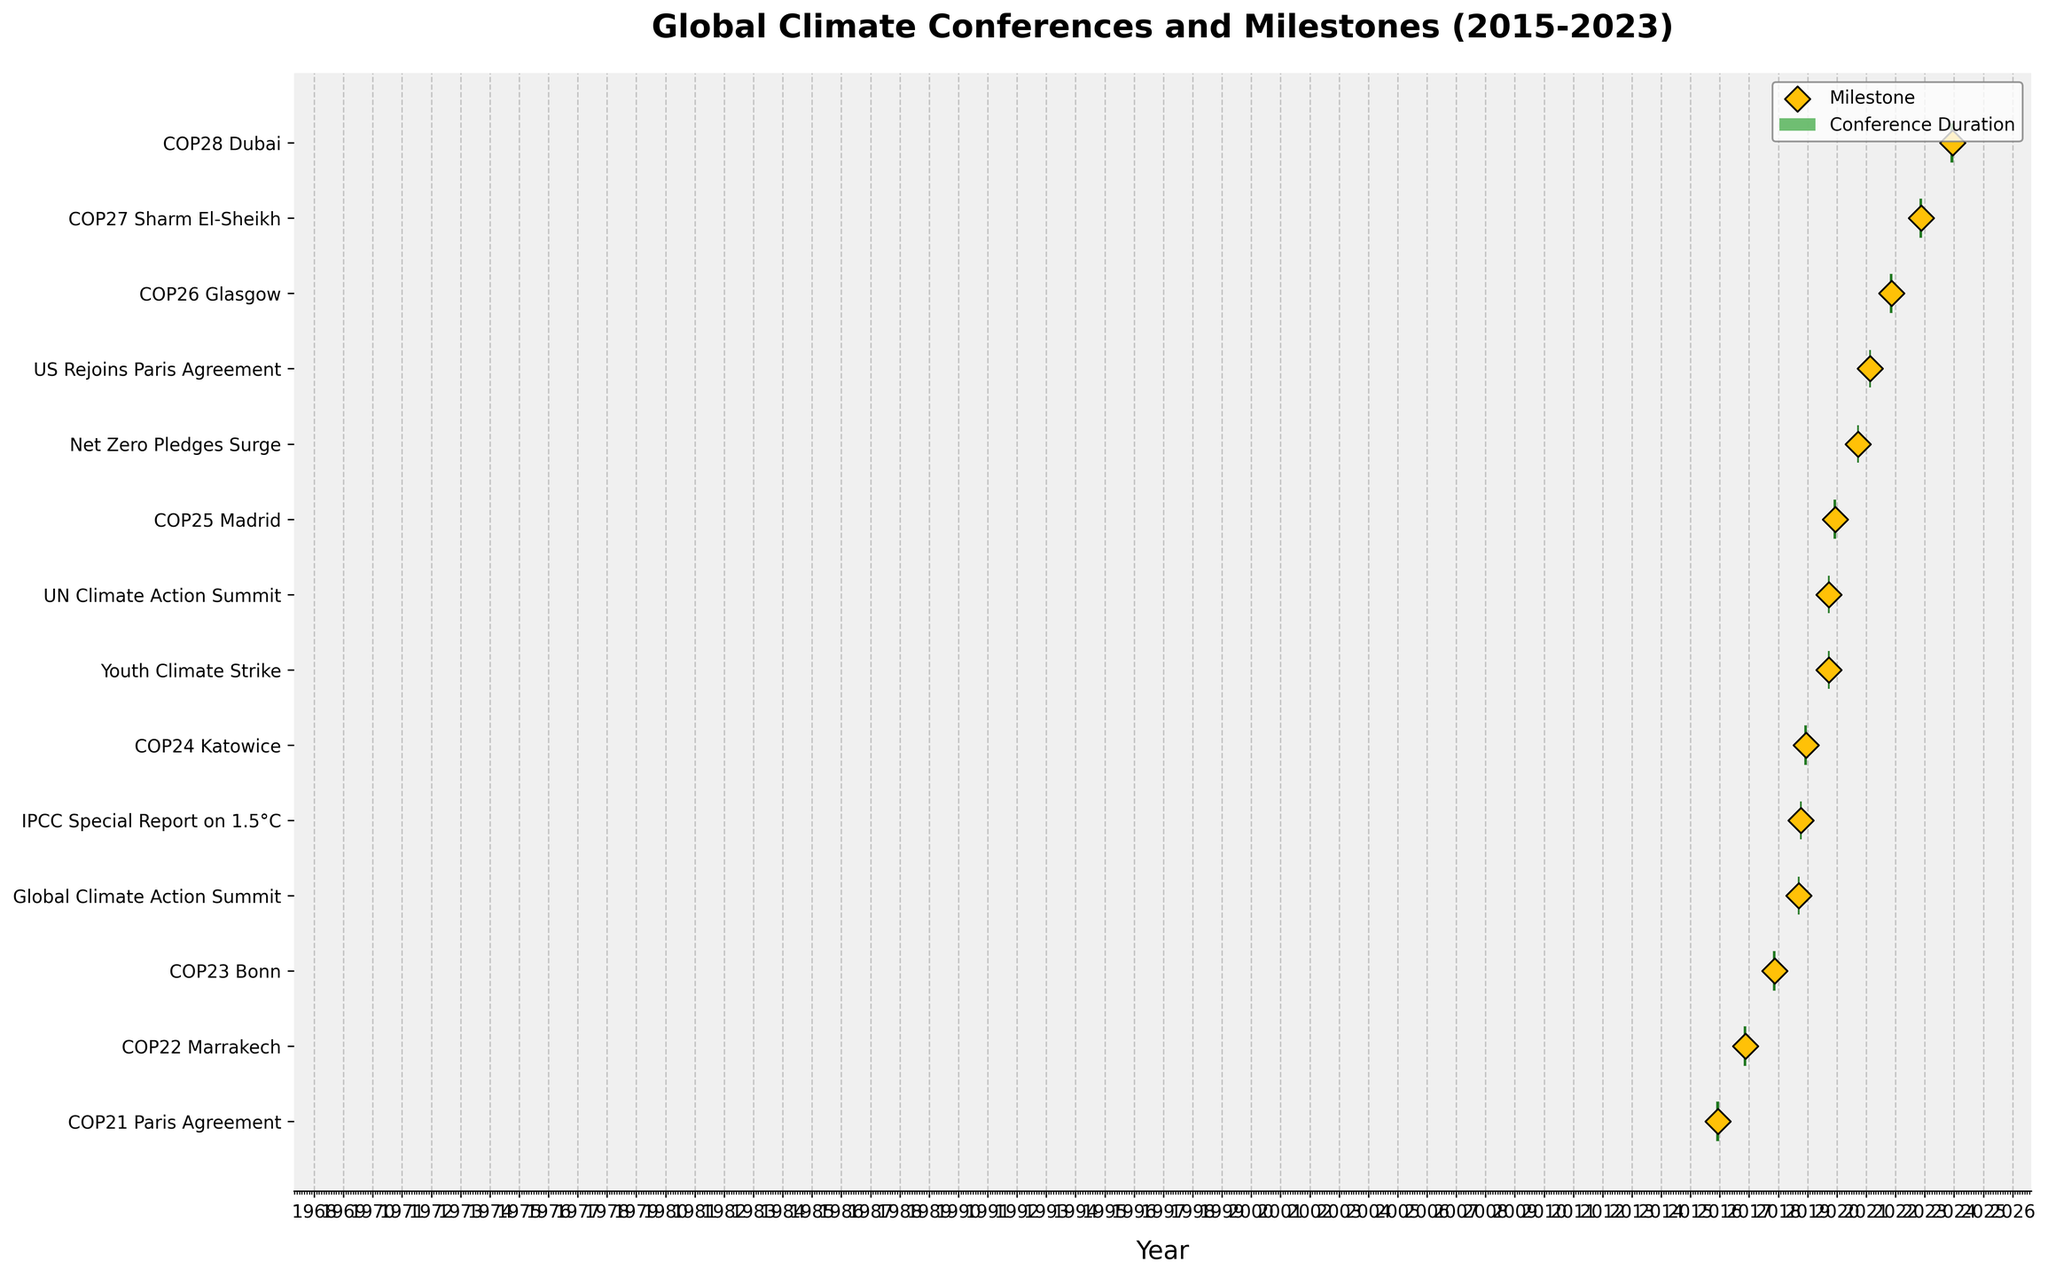What is the title of the figure? The title is always located at the top of the figure, specifying the main subject of the visualized data. In this case, it mentions the global climate conferences and milestones from 2015 to 2023.
Answer: Global Climate Conferences and Milestones (2015-2023) How many conferences are shown on the Gantt chart? Count the number of unique conference entries listed vertically on the y-axis. Each conference is represented by a horizontal bar.
Answer: 8 Which conference has the longest duration? Identify which horizontal bar representing a conference spans the most dates on the x-axis. This would indicate the longest period between the start and end dates.
Answer: COP24 Katowice Which conference took place right before COP25 Madrid? Locate COP25 Madrid on the y-axis and then identify the conference listed immediately above it, which indicates it happened right before COP25.
Answer: COP24 Katowice What milestone is marked at the end of COP21 Paris Agreement? Look for COP21 Paris Agreement on the y-axis, then find the milestone symbol (diamond shape) on the right side of its corresponding horizontal bar, which marks the milestone achieved.
Answer: Paris Agreement adopted How many milestones are achieved in 2019? Identify all the diamond-shaped milestone markers on the Gantt chart and count those occurring within the 2019 range on the x-axis.
Answer: 3 Compare the length of COP23 Bonn and COP26 Glasgow. Which one is longer? Measure the horizontal length of the bars corresponding to COP23 Bonn and COP26 Glasgow on the x-axis, noting which one extends over more days.
Answer: COP26 Glasgow Of COP21 Paris Agreement and COP27 Sharm El-Sheikh, which conference started later in the year? Examine the start dates displayed on the x-axis for COP21 Paris Agreement and COP27 Sharm El-Sheikh and compare them to see which is later.
Answer: COP27 Sharm El-Sheikh Did any conference take place in 2020? Check the x-axis for the year 2020 and see if any horizontal bar crosses this period, indicating a conference held during that year.
Answer: No What important milestone occurred after COP28 Dubai? Locate COP28 Dubai on the y-axis and identify the milestone marker at the end of its bar, noting the milestone description.
Answer: Global Stocktake completed 